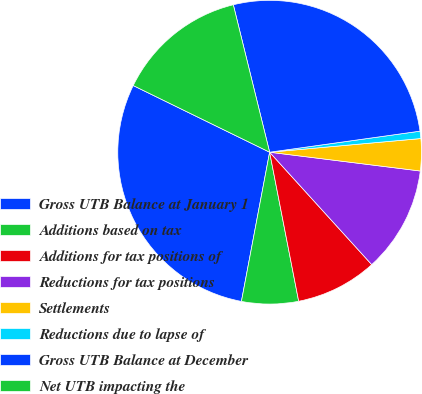<chart> <loc_0><loc_0><loc_500><loc_500><pie_chart><fcel>Gross UTB Balance at January 1<fcel>Additions based on tax<fcel>Additions for tax positions of<fcel>Reductions for tax positions<fcel>Settlements<fcel>Reductions due to lapse of<fcel>Gross UTB Balance at December<fcel>Net UTB impacting the<nl><fcel>29.26%<fcel>6.04%<fcel>8.67%<fcel>11.29%<fcel>3.41%<fcel>0.78%<fcel>26.63%<fcel>13.92%<nl></chart> 